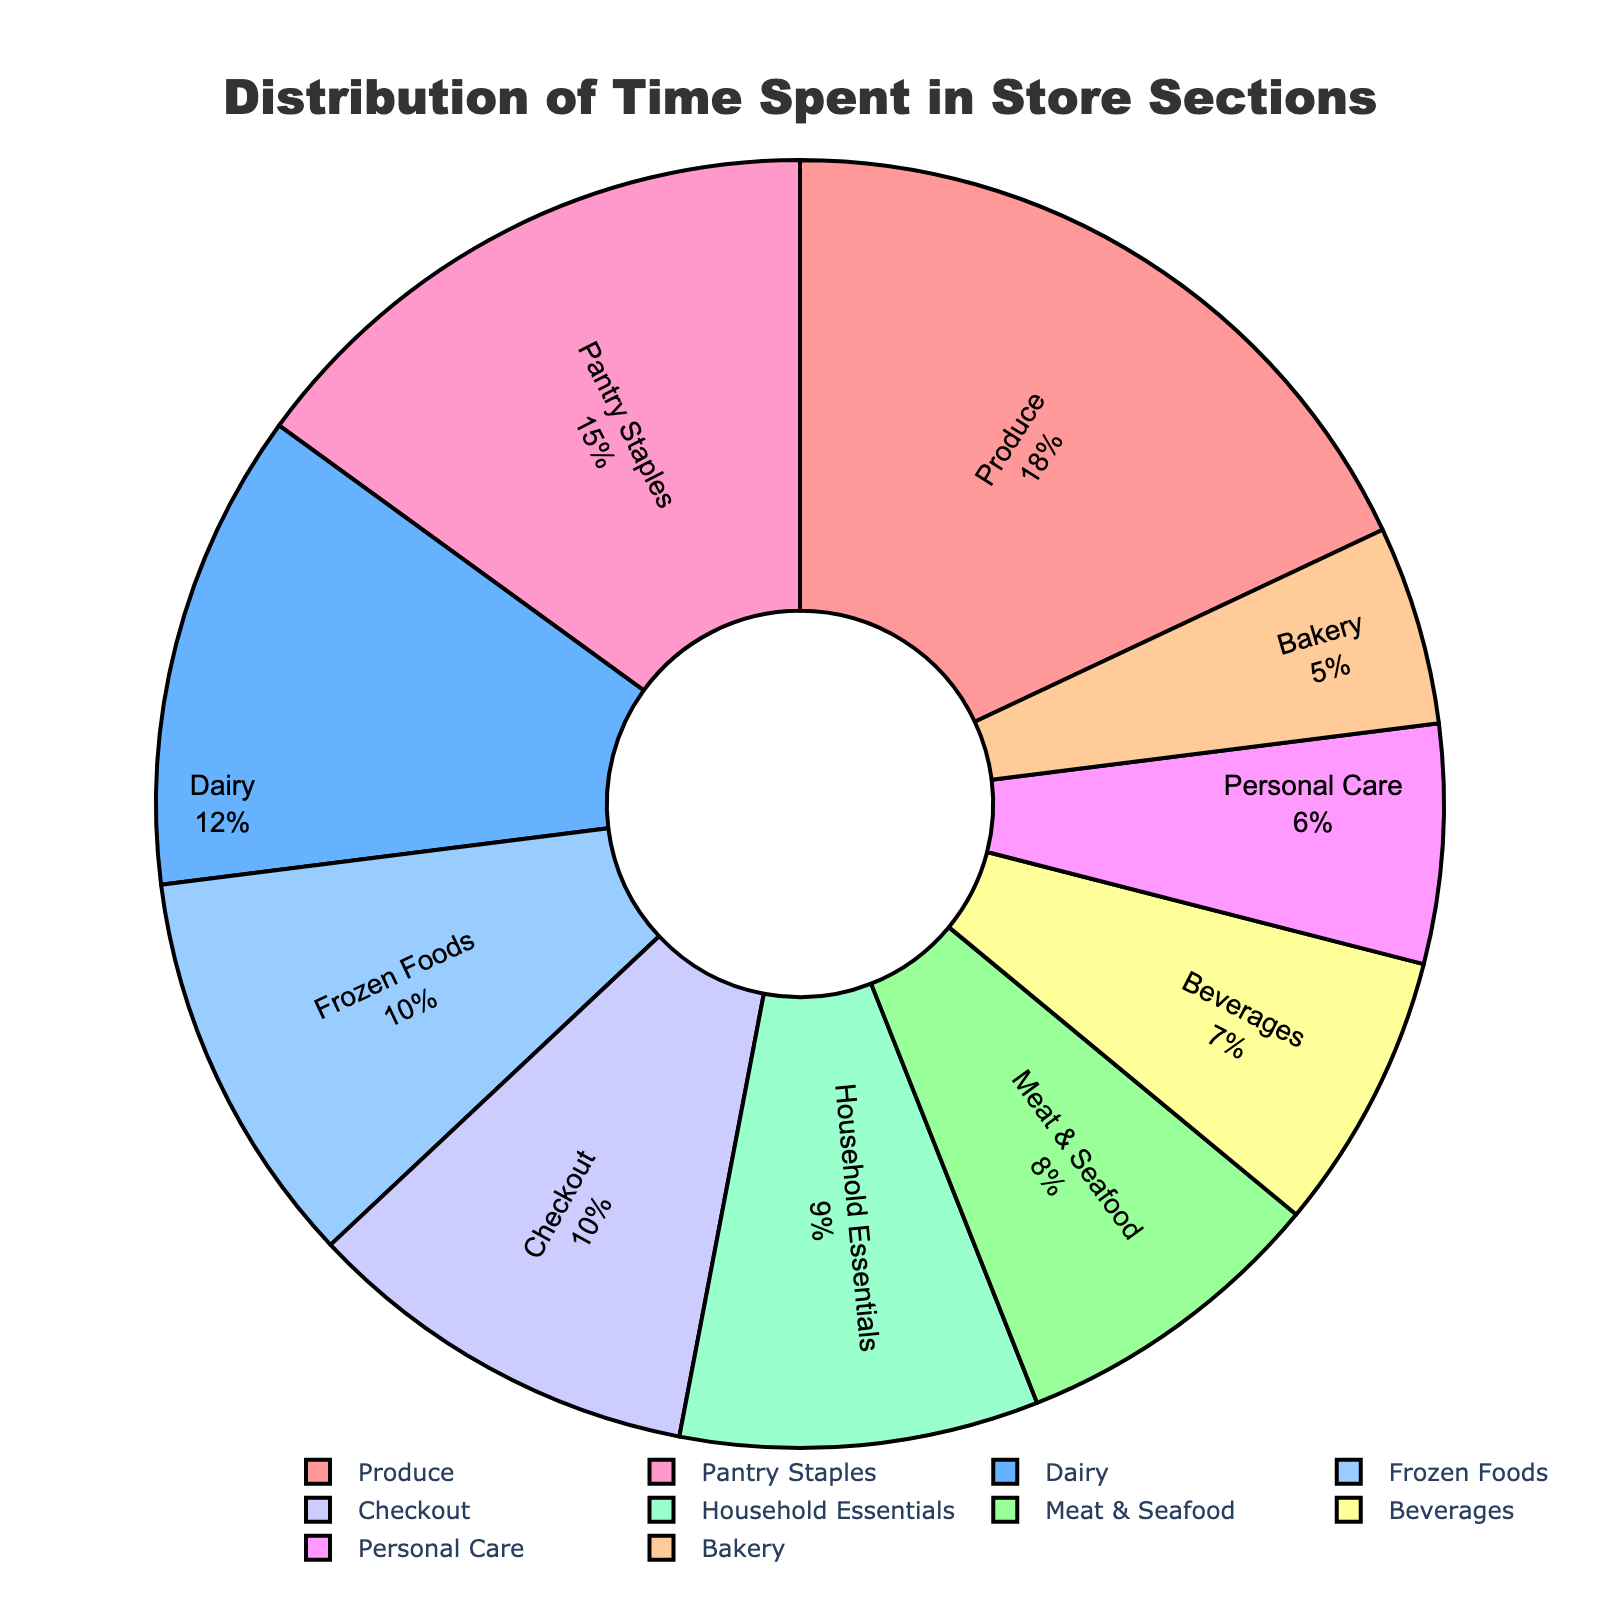Which section do efficient shoppers spend the most time in? By referring to the figure, we look for the section with the largest percentage. Produce is labeled with 18%, which is the highest among all sections.
Answer: Produce Between Meat & Seafood and Dairy, which section has a higher percentage of time spent by efficient shoppers? By comparing the percentages for Meat & Seafood (8%) and Dairy (12%) in the figure, Dairy has a higher percentage.
Answer: Dairy What is the combined percentage of time spent in the Bakery and Personal Care sections? We look at the percentages for Bakery (5%) and Personal Care (6%) and sum them up: 5% + 6% = 11%.
Answer: 11% Which section has a smaller percentage of time spent: Frozen Foods or Beverages? By comparing the percentages for Frozen Foods (10%) and Beverages (7%), we see that Beverages has a smaller percentage.
Answer: Beverages How much more time do efficient shoppers spend in Pantry Staples compared to Household Essentials? We note the percentages for Pantry Staples (15%) and Household Essentials (9%). The difference is 15% - 9% = 6%.
Answer: 6% What is the percentage difference between the section with the highest and the section with the lowest time spent? The highest percentage is Produce with 18%, and the lowest is Bakery with 5%. The difference is 18% - 5% = 13%.
Answer: 13% Is there any section where efficient shoppers spend an equal amount of time compared to the Checkout section? Efficient shoppers spend 10% of their time in the Checkout section. The only other section with 10% is Frozen Foods.
Answer: Frozen Foods Which two sections combined make up exactly 20% of the time spent by efficient shoppers? By looking for combinations whose percentages add up to 20%, Bakery (5%) + Personal Care (6%) + Household Essentials (9%) is the only pair that adds to 20%.
Answer: Bakery and Personal Care If the time spent in Frozen Foods and Beverages is combined, how does it compare to the time spent in Pantry Staples? The sum of Frozen Foods (10%) and Beverages (7%) is 17%, which is smaller than the time spent in Pantry Staples (15%).
Answer: Smaller What is the average time spent in the Produce, Dairy, and Meat & Seafood sections? The percentages are Produce (18%), Dairy (12%), and Meat & Seafood (8%). Sum them up for a total of 38%, and then divide by 3 to get: 38% / 3 ≈ 12.67%.
Answer: 12.67% 